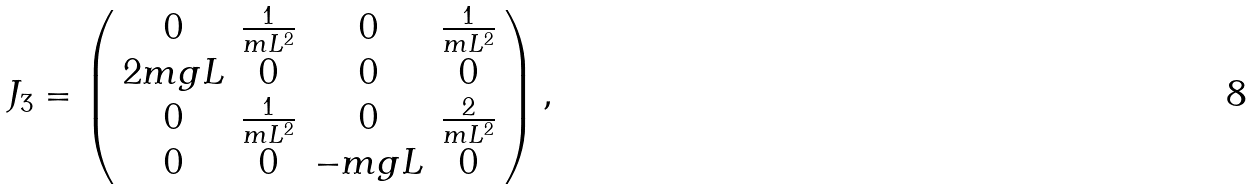<formula> <loc_0><loc_0><loc_500><loc_500>J _ { 3 } = \left ( \begin{array} { c c c c } 0 & \frac { 1 } { m L ^ { 2 } } & 0 & \frac { 1 } { m L ^ { 2 } } \\ 2 m g L & 0 & 0 & 0 \\ 0 & \frac { 1 } { m L ^ { 2 } } & 0 & \frac { 2 } { m L ^ { 2 } } \\ 0 & 0 & - m g L & 0 \\ \end{array} \right ) ,</formula> 